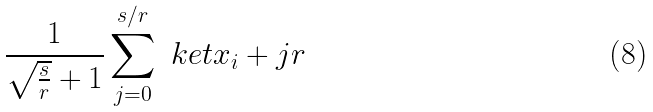Convert formula to latex. <formula><loc_0><loc_0><loc_500><loc_500>\frac { 1 } { \sqrt { \frac { s } { r } } + 1 } \sum _ { j = 0 } ^ { s / r } \ k e t { x _ { i } + j r }</formula> 